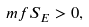Convert formula to latex. <formula><loc_0><loc_0><loc_500><loc_500>\ m f { S } _ { E } > 0 ,</formula> 